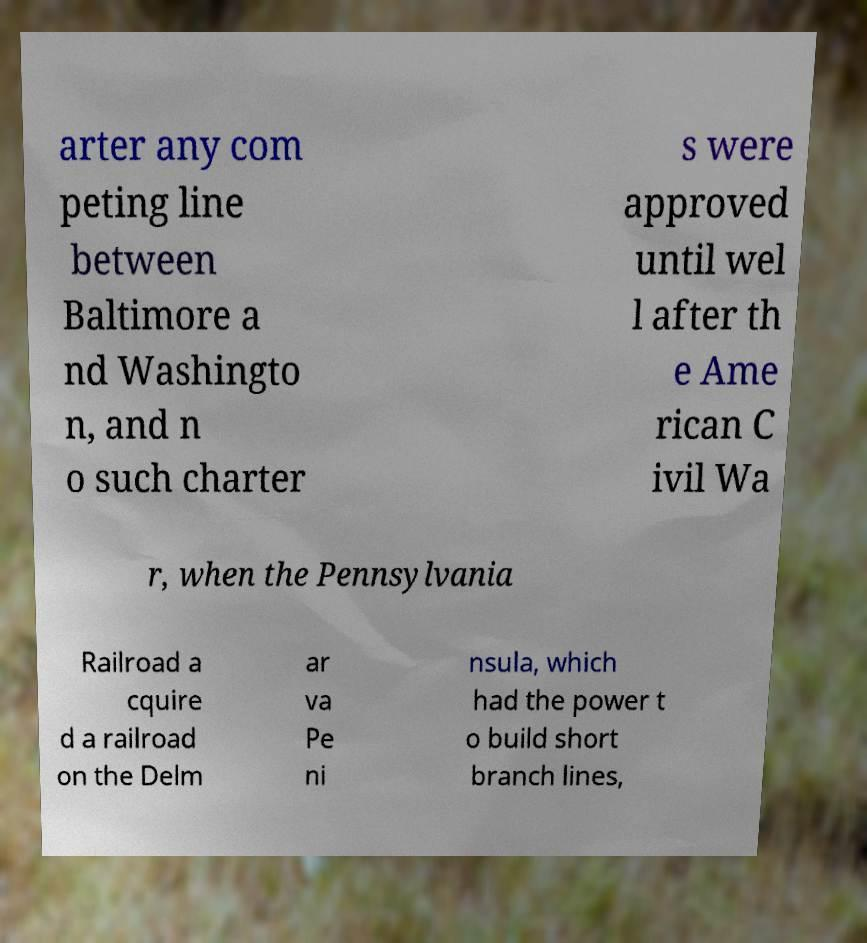For documentation purposes, I need the text within this image transcribed. Could you provide that? arter any com peting line between Baltimore a nd Washingto n, and n o such charter s were approved until wel l after th e Ame rican C ivil Wa r, when the Pennsylvania Railroad a cquire d a railroad on the Delm ar va Pe ni nsula, which had the power t o build short branch lines, 